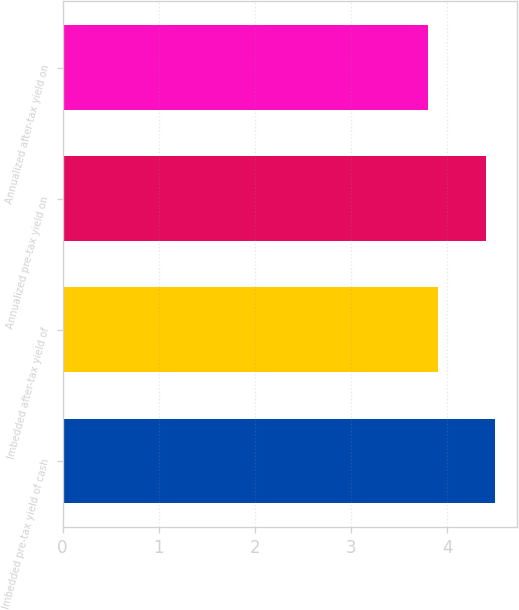Convert chart. <chart><loc_0><loc_0><loc_500><loc_500><bar_chart><fcel>Imbedded pre-tax yield of cash<fcel>Imbedded after-tax yield of<fcel>Annualized pre-tax yield on<fcel>Annualized after-tax yield on<nl><fcel>4.5<fcel>3.9<fcel>4.4<fcel>3.8<nl></chart> 